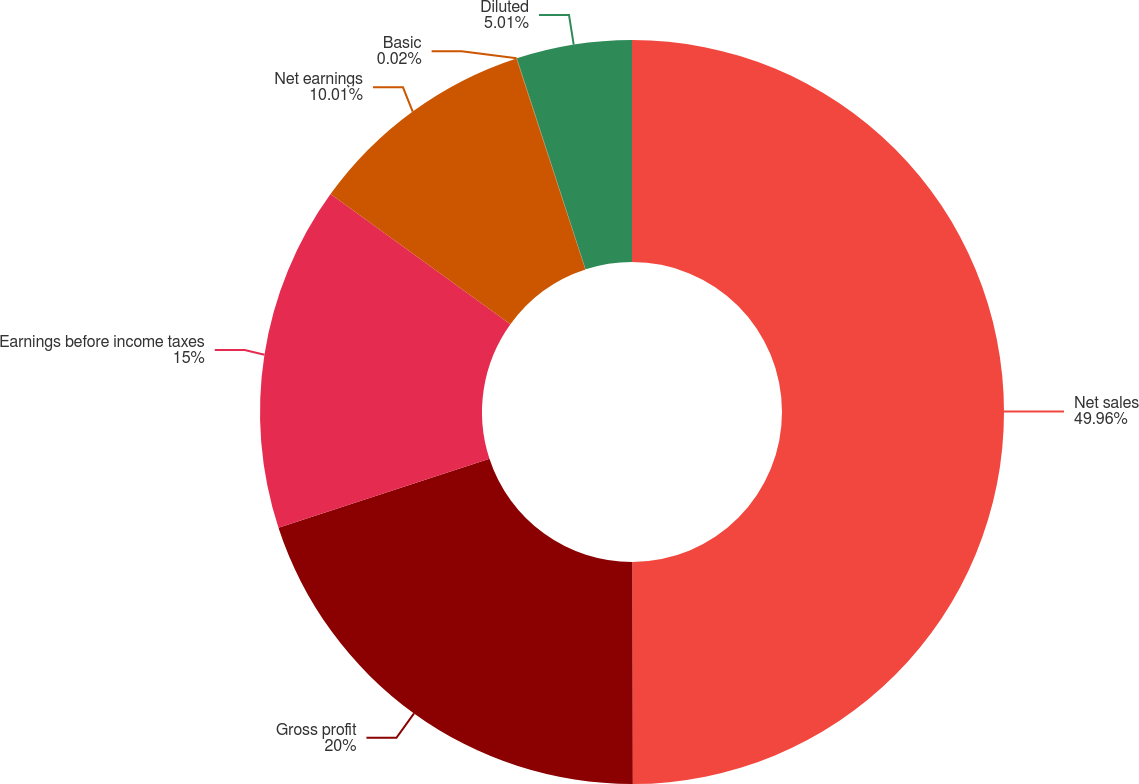Convert chart to OTSL. <chart><loc_0><loc_0><loc_500><loc_500><pie_chart><fcel>Net sales<fcel>Gross profit<fcel>Earnings before income taxes<fcel>Net earnings<fcel>Basic<fcel>Diluted<nl><fcel>49.97%<fcel>20.0%<fcel>15.0%<fcel>10.01%<fcel>0.02%<fcel>5.01%<nl></chart> 